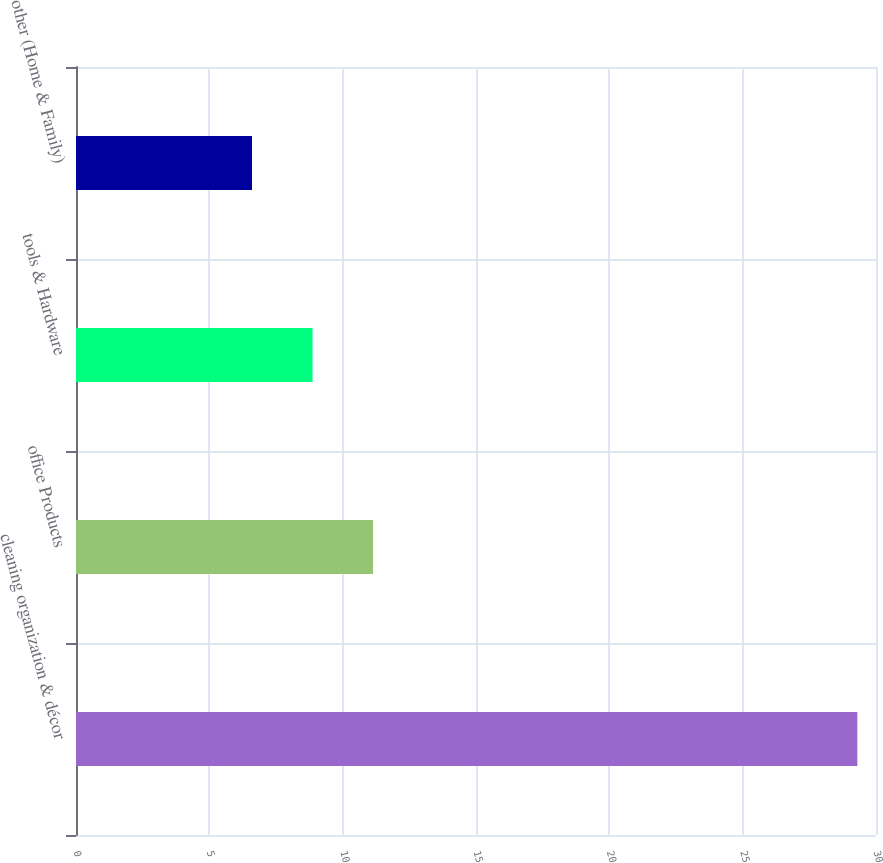Convert chart to OTSL. <chart><loc_0><loc_0><loc_500><loc_500><bar_chart><fcel>cleaning organization & décor<fcel>office Products<fcel>tools & Hardware<fcel>other (Home & Family)<nl><fcel>29.3<fcel>11.14<fcel>8.87<fcel>6.6<nl></chart> 